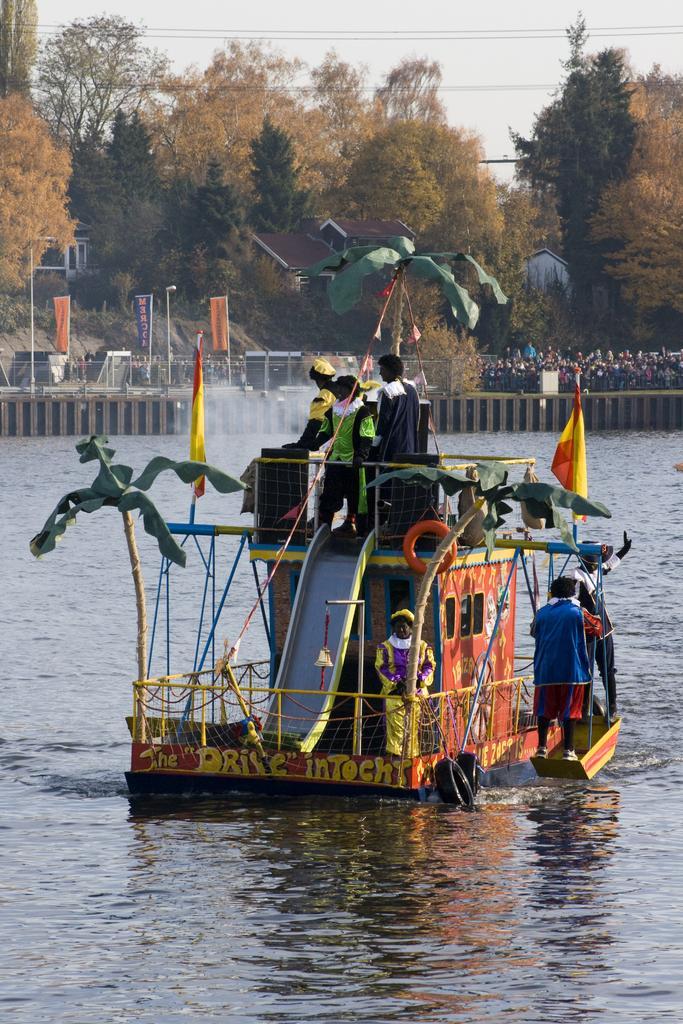In one or two sentences, can you explain what this image depicts? In this image, we can see persons on the boat which is floating on the water. There are some trees at the top of the image. 